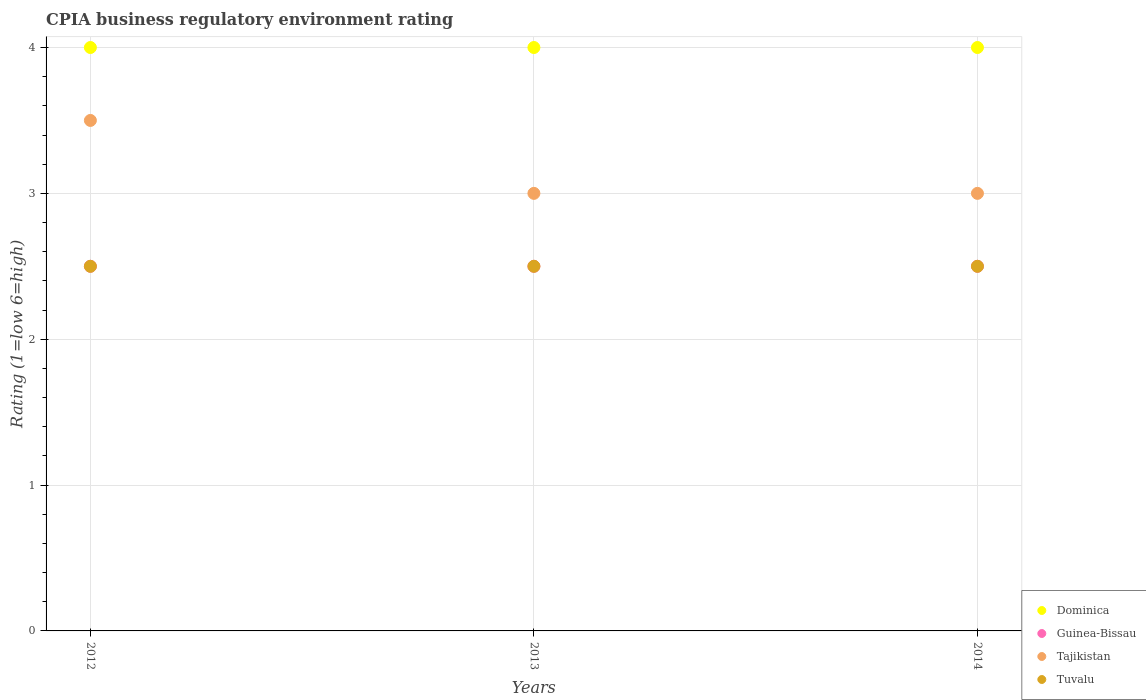How many different coloured dotlines are there?
Your response must be concise. 4. What is the CPIA rating in Guinea-Bissau in 2014?
Your response must be concise. 2.5. In which year was the CPIA rating in Tuvalu minimum?
Offer a very short reply. 2012. What is the difference between the CPIA rating in Tajikistan in 2012 and that in 2014?
Provide a succinct answer. 0.5. What is the average CPIA rating in Dominica per year?
Keep it short and to the point. 4. In how many years, is the CPIA rating in Tuvalu greater than 2.4?
Provide a short and direct response. 3. Is the difference between the CPIA rating in Tuvalu in 2012 and 2013 greater than the difference between the CPIA rating in Tajikistan in 2012 and 2013?
Your response must be concise. No. What is the difference between the highest and the second highest CPIA rating in Tajikistan?
Your response must be concise. 0.5. In how many years, is the CPIA rating in Tuvalu greater than the average CPIA rating in Tuvalu taken over all years?
Make the answer very short. 0. Is the sum of the CPIA rating in Tajikistan in 2013 and 2014 greater than the maximum CPIA rating in Dominica across all years?
Your response must be concise. Yes. Is it the case that in every year, the sum of the CPIA rating in Dominica and CPIA rating in Guinea-Bissau  is greater than the CPIA rating in Tuvalu?
Keep it short and to the point. Yes. Does the CPIA rating in Dominica monotonically increase over the years?
Your response must be concise. No. Is the CPIA rating in Dominica strictly less than the CPIA rating in Tuvalu over the years?
Your answer should be very brief. No. How many years are there in the graph?
Give a very brief answer. 3. Does the graph contain any zero values?
Ensure brevity in your answer.  No. Does the graph contain grids?
Offer a very short reply. Yes. How many legend labels are there?
Make the answer very short. 4. What is the title of the graph?
Provide a short and direct response. CPIA business regulatory environment rating. What is the label or title of the Y-axis?
Keep it short and to the point. Rating (1=low 6=high). What is the Rating (1=low 6=high) of Guinea-Bissau in 2012?
Provide a succinct answer. 2.5. What is the Rating (1=low 6=high) in Tuvalu in 2012?
Ensure brevity in your answer.  2.5. What is the Rating (1=low 6=high) of Dominica in 2013?
Your answer should be very brief. 4. What is the Rating (1=low 6=high) of Guinea-Bissau in 2013?
Ensure brevity in your answer.  2.5. What is the Rating (1=low 6=high) in Tuvalu in 2013?
Ensure brevity in your answer.  2.5. What is the Rating (1=low 6=high) in Guinea-Bissau in 2014?
Provide a succinct answer. 2.5. Across all years, what is the maximum Rating (1=low 6=high) of Tajikistan?
Your answer should be very brief. 3.5. Across all years, what is the maximum Rating (1=low 6=high) in Tuvalu?
Offer a very short reply. 2.5. Across all years, what is the minimum Rating (1=low 6=high) of Dominica?
Ensure brevity in your answer.  4. Across all years, what is the minimum Rating (1=low 6=high) of Guinea-Bissau?
Make the answer very short. 2.5. Across all years, what is the minimum Rating (1=low 6=high) in Tajikistan?
Keep it short and to the point. 3. What is the total Rating (1=low 6=high) of Dominica in the graph?
Your response must be concise. 12. What is the total Rating (1=low 6=high) in Tajikistan in the graph?
Your response must be concise. 9.5. What is the total Rating (1=low 6=high) of Tuvalu in the graph?
Provide a short and direct response. 7.5. What is the difference between the Rating (1=low 6=high) in Dominica in 2012 and that in 2013?
Your response must be concise. 0. What is the difference between the Rating (1=low 6=high) in Guinea-Bissau in 2012 and that in 2013?
Your answer should be compact. 0. What is the difference between the Rating (1=low 6=high) of Tajikistan in 2012 and that in 2013?
Your response must be concise. 0.5. What is the difference between the Rating (1=low 6=high) of Tuvalu in 2012 and that in 2013?
Offer a terse response. 0. What is the difference between the Rating (1=low 6=high) in Dominica in 2012 and that in 2014?
Ensure brevity in your answer.  0. What is the difference between the Rating (1=low 6=high) in Guinea-Bissau in 2012 and that in 2014?
Give a very brief answer. 0. What is the difference between the Rating (1=low 6=high) of Tuvalu in 2012 and that in 2014?
Your response must be concise. 0. What is the difference between the Rating (1=low 6=high) of Dominica in 2013 and that in 2014?
Your response must be concise. 0. What is the difference between the Rating (1=low 6=high) in Guinea-Bissau in 2013 and that in 2014?
Provide a short and direct response. 0. What is the difference between the Rating (1=low 6=high) of Dominica in 2012 and the Rating (1=low 6=high) of Guinea-Bissau in 2013?
Give a very brief answer. 1.5. What is the difference between the Rating (1=low 6=high) in Tajikistan in 2012 and the Rating (1=low 6=high) in Tuvalu in 2013?
Provide a short and direct response. 1. What is the difference between the Rating (1=low 6=high) of Dominica in 2012 and the Rating (1=low 6=high) of Guinea-Bissau in 2014?
Make the answer very short. 1.5. What is the difference between the Rating (1=low 6=high) in Guinea-Bissau in 2012 and the Rating (1=low 6=high) in Tajikistan in 2014?
Your answer should be very brief. -0.5. What is the difference between the Rating (1=low 6=high) in Guinea-Bissau in 2012 and the Rating (1=low 6=high) in Tuvalu in 2014?
Make the answer very short. 0. What is the difference between the Rating (1=low 6=high) of Guinea-Bissau in 2013 and the Rating (1=low 6=high) of Tajikistan in 2014?
Give a very brief answer. -0.5. What is the difference between the Rating (1=low 6=high) in Guinea-Bissau in 2013 and the Rating (1=low 6=high) in Tuvalu in 2014?
Your answer should be very brief. 0. What is the average Rating (1=low 6=high) of Guinea-Bissau per year?
Offer a very short reply. 2.5. What is the average Rating (1=low 6=high) of Tajikistan per year?
Your answer should be compact. 3.17. In the year 2012, what is the difference between the Rating (1=low 6=high) in Dominica and Rating (1=low 6=high) in Guinea-Bissau?
Give a very brief answer. 1.5. In the year 2012, what is the difference between the Rating (1=low 6=high) of Dominica and Rating (1=low 6=high) of Tajikistan?
Offer a very short reply. 0.5. In the year 2012, what is the difference between the Rating (1=low 6=high) of Dominica and Rating (1=low 6=high) of Tuvalu?
Provide a short and direct response. 1.5. In the year 2012, what is the difference between the Rating (1=low 6=high) of Guinea-Bissau and Rating (1=low 6=high) of Tajikistan?
Provide a short and direct response. -1. In the year 2013, what is the difference between the Rating (1=low 6=high) of Tajikistan and Rating (1=low 6=high) of Tuvalu?
Keep it short and to the point. 0.5. In the year 2014, what is the difference between the Rating (1=low 6=high) of Dominica and Rating (1=low 6=high) of Tajikistan?
Keep it short and to the point. 1. In the year 2014, what is the difference between the Rating (1=low 6=high) in Dominica and Rating (1=low 6=high) in Tuvalu?
Provide a short and direct response. 1.5. In the year 2014, what is the difference between the Rating (1=low 6=high) in Guinea-Bissau and Rating (1=low 6=high) in Tajikistan?
Offer a terse response. -0.5. In the year 2014, what is the difference between the Rating (1=low 6=high) in Guinea-Bissau and Rating (1=low 6=high) in Tuvalu?
Keep it short and to the point. 0. In the year 2014, what is the difference between the Rating (1=low 6=high) of Tajikistan and Rating (1=low 6=high) of Tuvalu?
Keep it short and to the point. 0.5. What is the ratio of the Rating (1=low 6=high) in Dominica in 2012 to that in 2013?
Your answer should be compact. 1. What is the ratio of the Rating (1=low 6=high) in Guinea-Bissau in 2012 to that in 2013?
Provide a short and direct response. 1. What is the ratio of the Rating (1=low 6=high) of Tuvalu in 2012 to that in 2013?
Provide a short and direct response. 1. What is the ratio of the Rating (1=low 6=high) of Dominica in 2012 to that in 2014?
Make the answer very short. 1. What is the ratio of the Rating (1=low 6=high) in Guinea-Bissau in 2012 to that in 2014?
Your answer should be very brief. 1. What is the ratio of the Rating (1=low 6=high) in Dominica in 2013 to that in 2014?
Give a very brief answer. 1. What is the ratio of the Rating (1=low 6=high) in Tajikistan in 2013 to that in 2014?
Keep it short and to the point. 1. What is the ratio of the Rating (1=low 6=high) of Tuvalu in 2013 to that in 2014?
Your response must be concise. 1. What is the difference between the highest and the second highest Rating (1=low 6=high) of Dominica?
Make the answer very short. 0. What is the difference between the highest and the second highest Rating (1=low 6=high) of Tuvalu?
Make the answer very short. 0. What is the difference between the highest and the lowest Rating (1=low 6=high) in Dominica?
Offer a very short reply. 0. What is the difference between the highest and the lowest Rating (1=low 6=high) of Tuvalu?
Your answer should be very brief. 0. 